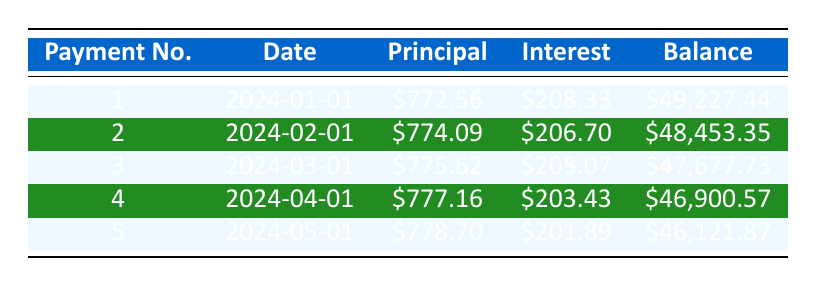What is the total monthly payment for this loan? The table specifies that the loan's monthly payment is listed as $943.56.
Answer: 943.56 How much of the first payment goes towards the principal? The first payment's principal portion is directly stated in the table as $772.56.
Answer: 772.56 What is the remaining balance after the second payment? The remaining balance after the second payment is shown in the table as $48,453.35.
Answer: 48,453.35 How much total interest will be paid over the life of the loan? The total interest paid is clearly indicated in the loan details section of the table as $6,613.70.
Answer: 6,613.70 What is the average principal payment over the first five payments? The sum of the principal payments is $772.56 + $774.09 + $775.62 + $777.16 + $778.70 = $3,878.13. There are 5 payments, so the average is $3,878.13 / 5 = $775.63.
Answer: 775.63 Is the interest payment for the third month greater than that for the first month? The interest payment for the third month is $205.07, while for the first month it is $208.33. Therefore, $205.07 is less than $208.33.
Answer: No What is the decrease in remaining balance from the first to the fifth payment? The remaining balance after the first payment is $49,227.44, and after the fifth payment, it is $46,121.87. The decrease is $49,227.44 - $46,121.87 = $3,105.57.
Answer: 3,105.57 Is the principal payment for the fourth month higher than $750? The fourth month’s principal payment is $777.16, which is indeed higher than $750.
Answer: Yes What is the total amount paid in interest for the first three payments? The interest payments for the first three months are $208.33 + $206.70 + $205.07 = $620.10.
Answer: 620.10 